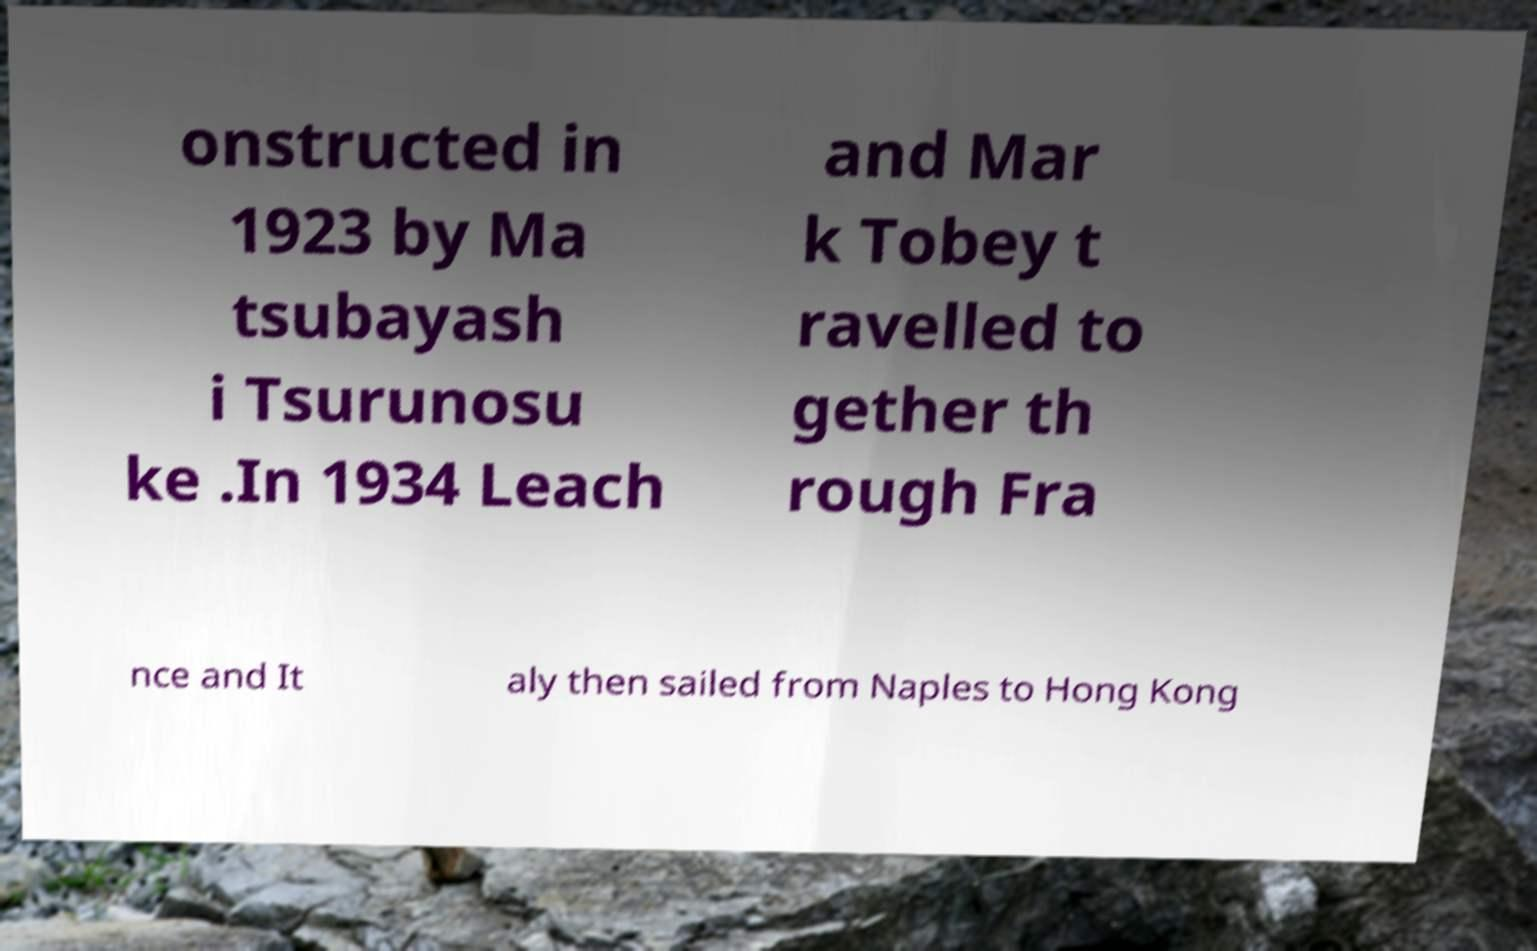Can you read and provide the text displayed in the image?This photo seems to have some interesting text. Can you extract and type it out for me? onstructed in 1923 by Ma tsubayash i Tsurunosu ke .In 1934 Leach and Mar k Tobey t ravelled to gether th rough Fra nce and It aly then sailed from Naples to Hong Kong 